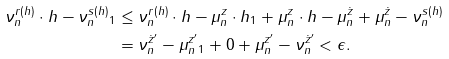<formula> <loc_0><loc_0><loc_500><loc_500>\| \nu _ { n } ^ { r ( h ) } \cdot h - \nu _ { n } ^ { s ( h ) } \| _ { 1 } & \leq \| \nu _ { n } ^ { r ( h ) } \cdot h - \mu _ { n } ^ { z } \cdot h \| _ { 1 } + \| \mu _ { n } ^ { z } \cdot h - \mu _ { n } ^ { \dot { z } } \| + \| \mu _ { n } ^ { \dot { z } } - \nu _ { n } ^ { s ( h ) } \| \\ & = \| \nu _ { n } ^ { \dot { z } ^ { \prime } } - \mu _ { n } ^ { z ^ { \prime } } \| _ { 1 } + 0 + \| \mu _ { n } ^ { z ^ { \prime } } - \nu _ { n } ^ { \dot { z } ^ { \prime } } \| < \epsilon .</formula> 